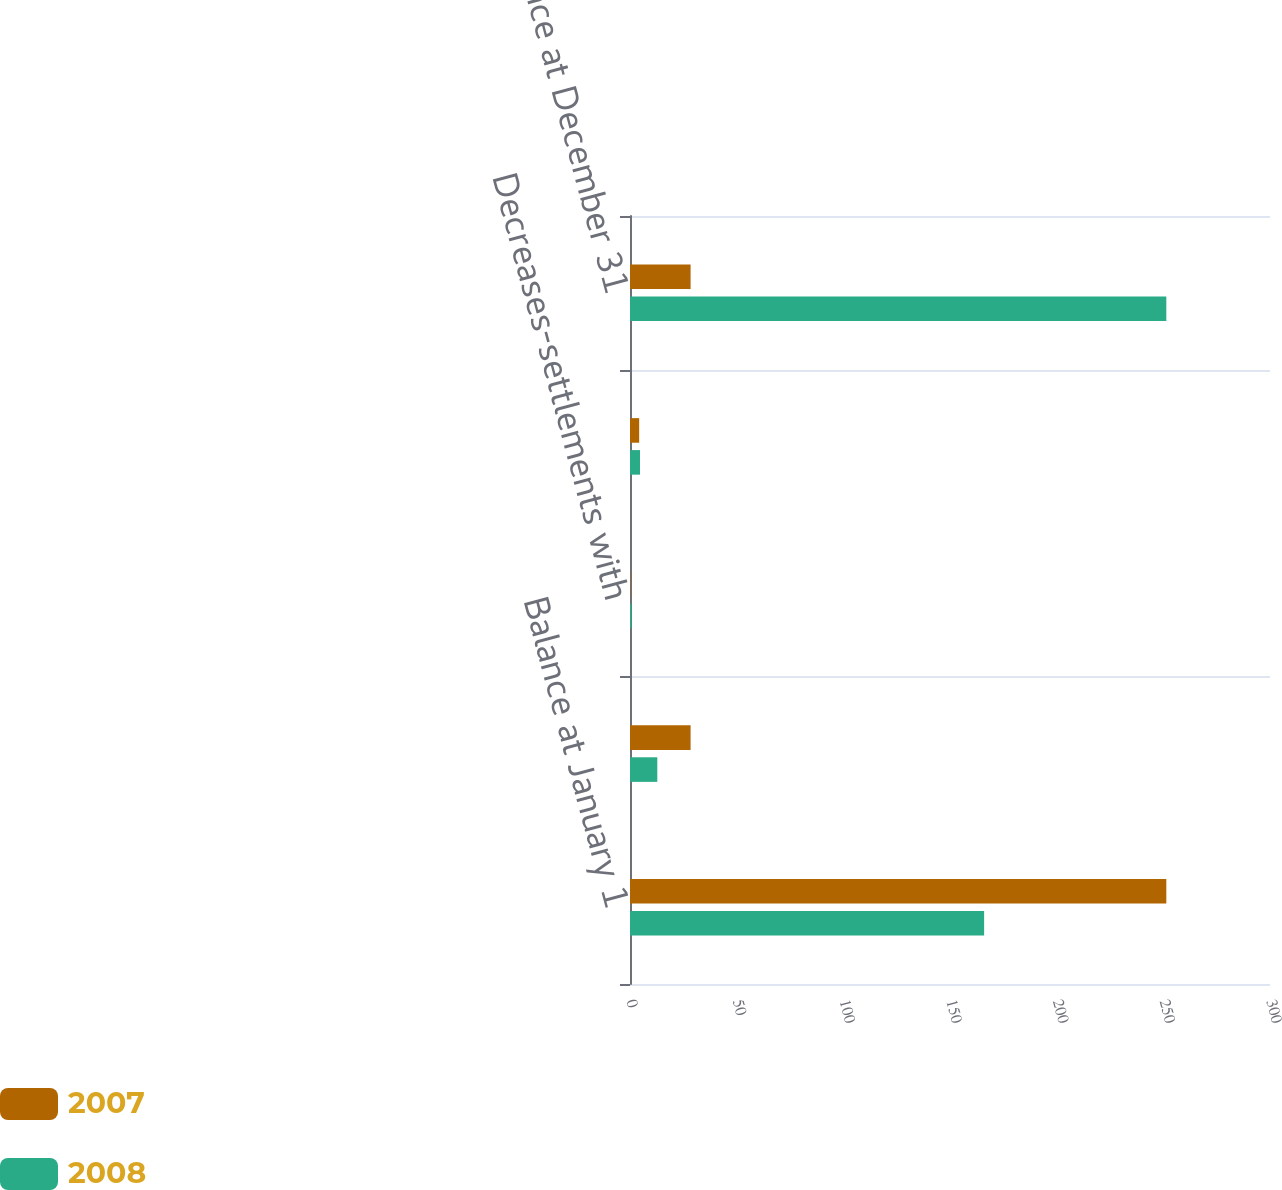<chart> <loc_0><loc_0><loc_500><loc_500><stacked_bar_chart><ecel><fcel>Balance at January 1<fcel>Increases-positions taken in<fcel>Decreases-settlements with<fcel>Decreases-lapse of applicable<fcel>Balance at December 31<nl><fcel>2007<fcel>251.4<fcel>28.4<fcel>0.2<fcel>4.3<fcel>28.4<nl><fcel>2008<fcel>166<fcel>12.8<fcel>0.7<fcel>4.7<fcel>251.4<nl></chart> 